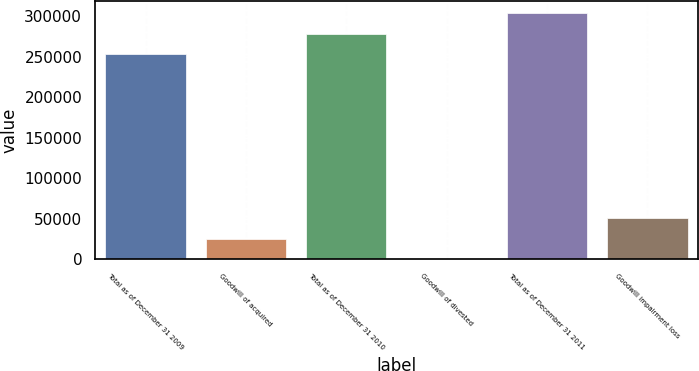<chart> <loc_0><loc_0><loc_500><loc_500><bar_chart><fcel>Total as of December 31 2009<fcel>Goodwill of acquired<fcel>Total as of December 31 2010<fcel>Goodwill of divested<fcel>Total as of December 31 2011<fcel>Goodwill impairment loss<nl><fcel>252664<fcel>25268.1<fcel>277930<fcel>1.89<fcel>303196<fcel>50534.3<nl></chart> 